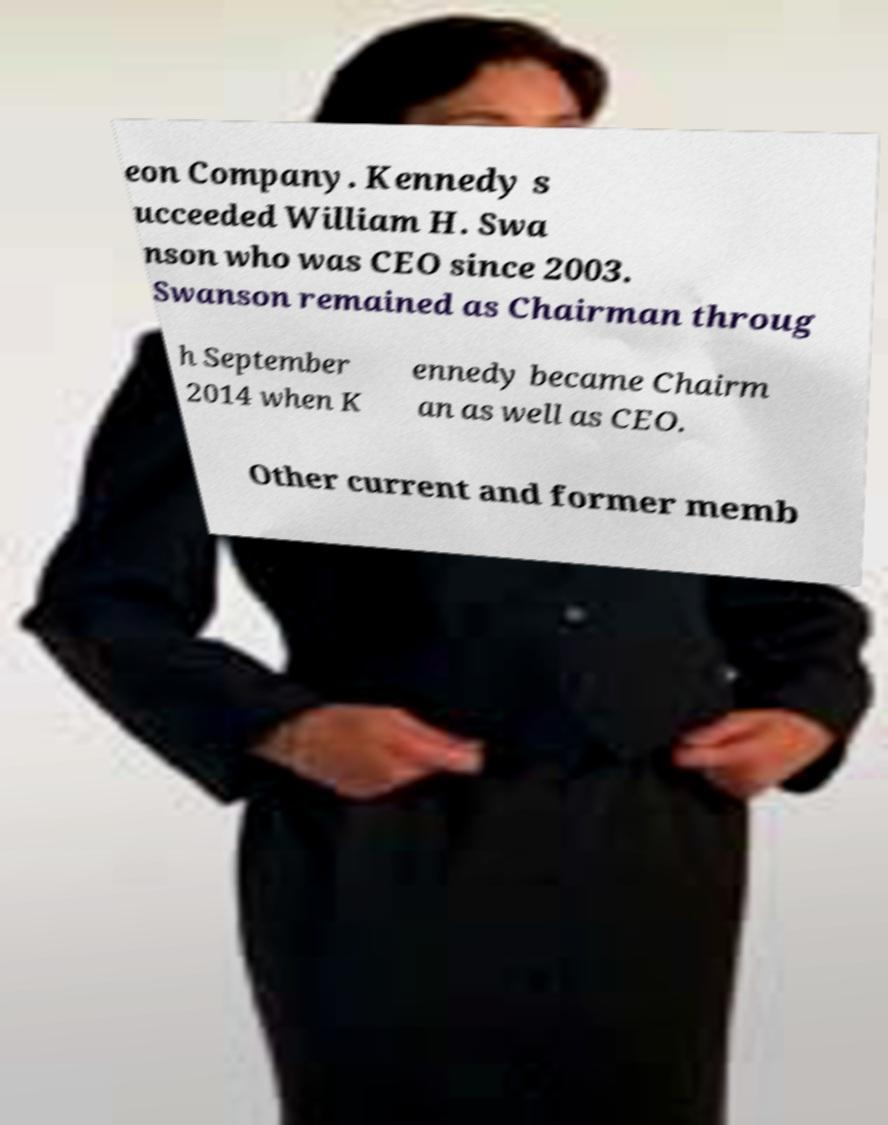Can you accurately transcribe the text from the provided image for me? eon Company. Kennedy s ucceeded William H. Swa nson who was CEO since 2003. Swanson remained as Chairman throug h September 2014 when K ennedy became Chairm an as well as CEO. Other current and former memb 